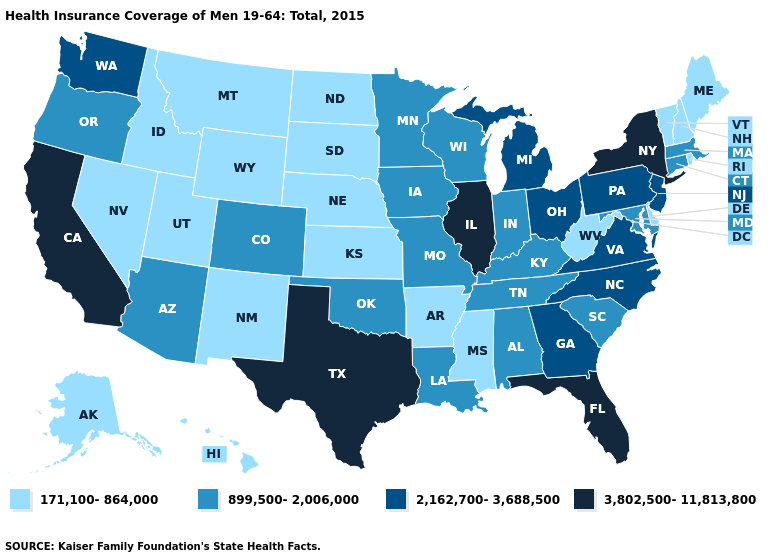Does Tennessee have the same value as Utah?
Write a very short answer. No. What is the highest value in states that border Nevada?
Give a very brief answer. 3,802,500-11,813,800. What is the value of Ohio?
Quick response, please. 2,162,700-3,688,500. Name the states that have a value in the range 171,100-864,000?
Short answer required. Alaska, Arkansas, Delaware, Hawaii, Idaho, Kansas, Maine, Mississippi, Montana, Nebraska, Nevada, New Hampshire, New Mexico, North Dakota, Rhode Island, South Dakota, Utah, Vermont, West Virginia, Wyoming. What is the value of Arizona?
Quick response, please. 899,500-2,006,000. Name the states that have a value in the range 3,802,500-11,813,800?
Give a very brief answer. California, Florida, Illinois, New York, Texas. What is the lowest value in the South?
Give a very brief answer. 171,100-864,000. Does Washington have the lowest value in the West?
Short answer required. No. Among the states that border New Hampshire , does Massachusetts have the highest value?
Quick response, please. Yes. What is the value of Nebraska?
Keep it brief. 171,100-864,000. Among the states that border Minnesota , does North Dakota have the highest value?
Short answer required. No. Name the states that have a value in the range 2,162,700-3,688,500?
Be succinct. Georgia, Michigan, New Jersey, North Carolina, Ohio, Pennsylvania, Virginia, Washington. Which states have the lowest value in the USA?
Short answer required. Alaska, Arkansas, Delaware, Hawaii, Idaho, Kansas, Maine, Mississippi, Montana, Nebraska, Nevada, New Hampshire, New Mexico, North Dakota, Rhode Island, South Dakota, Utah, Vermont, West Virginia, Wyoming. What is the value of Maryland?
Quick response, please. 899,500-2,006,000. Name the states that have a value in the range 3,802,500-11,813,800?
Answer briefly. California, Florida, Illinois, New York, Texas. 